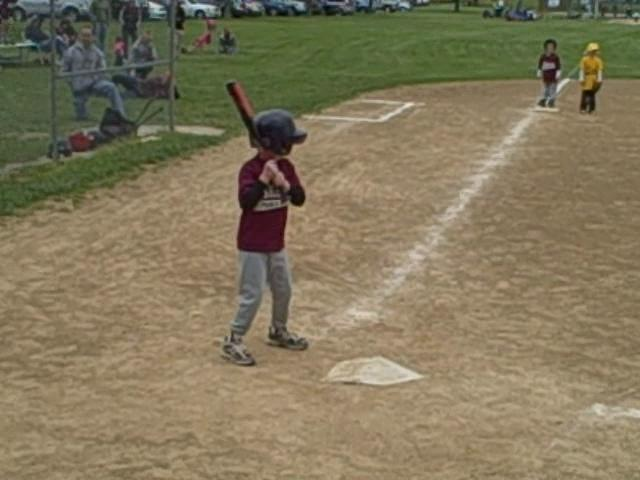What position does the player wearing yellow play? third base 